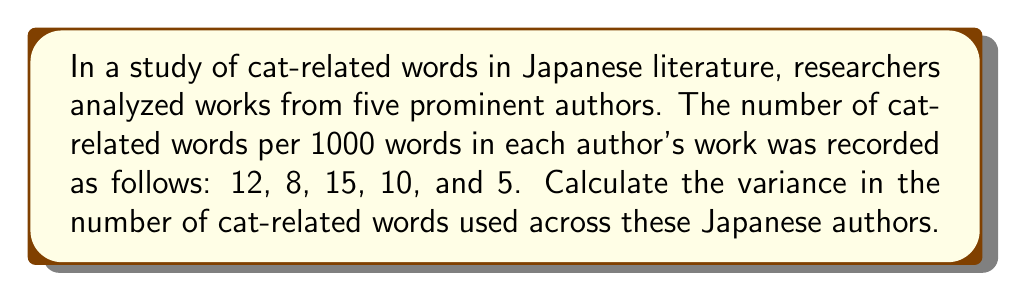Show me your answer to this math problem. To calculate the variance, we'll follow these steps:

1. Calculate the mean (μ) of the data:
   $$ \mu = \frac{12 + 8 + 15 + 10 + 5}{5} = 10 $$

2. Calculate the squared differences from the mean:
   $$ (12 - 10)^2 = 4 $$
   $$ (8 - 10)^2 = 4 $$
   $$ (15 - 10)^2 = 25 $$
   $$ (10 - 10)^2 = 0 $$
   $$ (5 - 10)^2 = 25 $$

3. Sum the squared differences:
   $$ 4 + 4 + 25 + 0 + 25 = 58 $$

4. Divide by the number of data points (n) to get the variance:
   $$ \text{Variance} = \frac{58}{5} = 11.6 $$

Thus, the variance in the number of cat-related words used across these Japanese authors is 11.6.
Answer: 11.6 